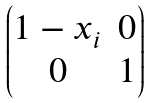<formula> <loc_0><loc_0><loc_500><loc_500>\begin{pmatrix} 1 - x _ { i } & 0 \\ 0 & 1 \\ \end{pmatrix}</formula> 